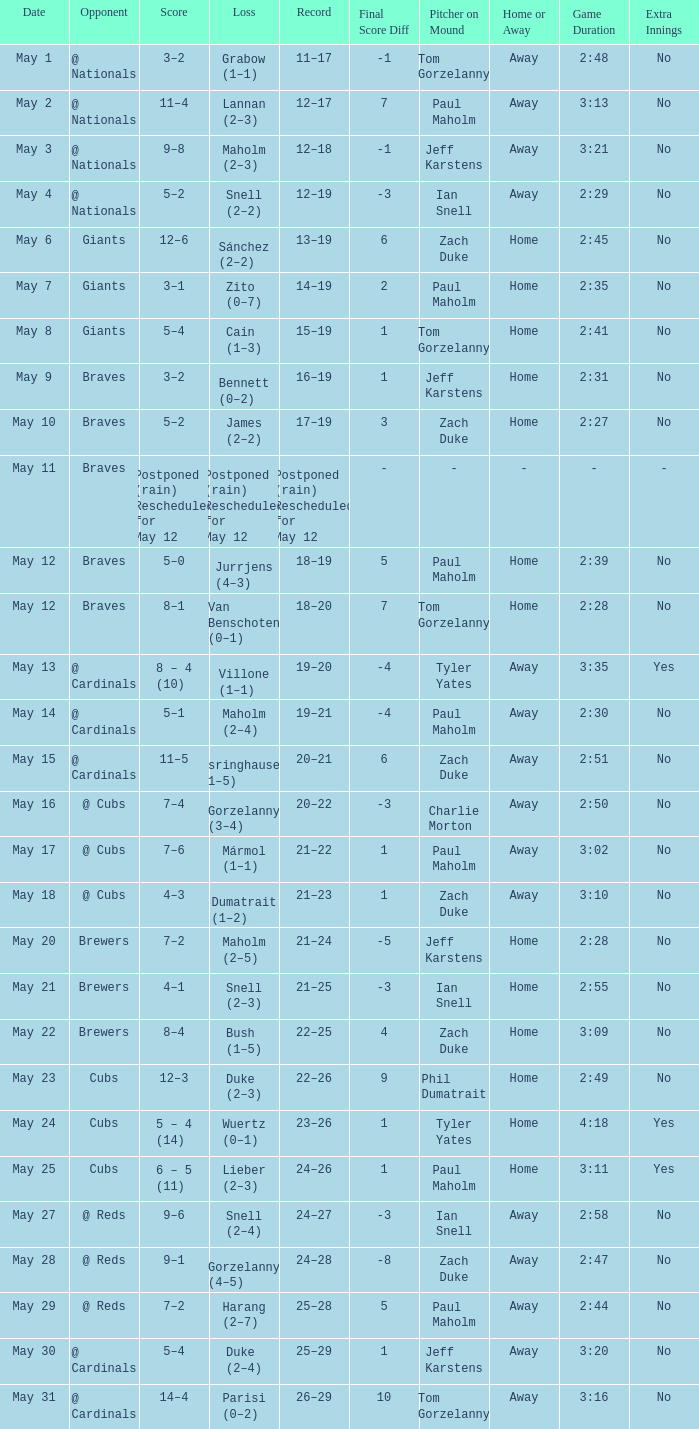What was the date of the game with a loss of Bush (1–5)? May 22. 